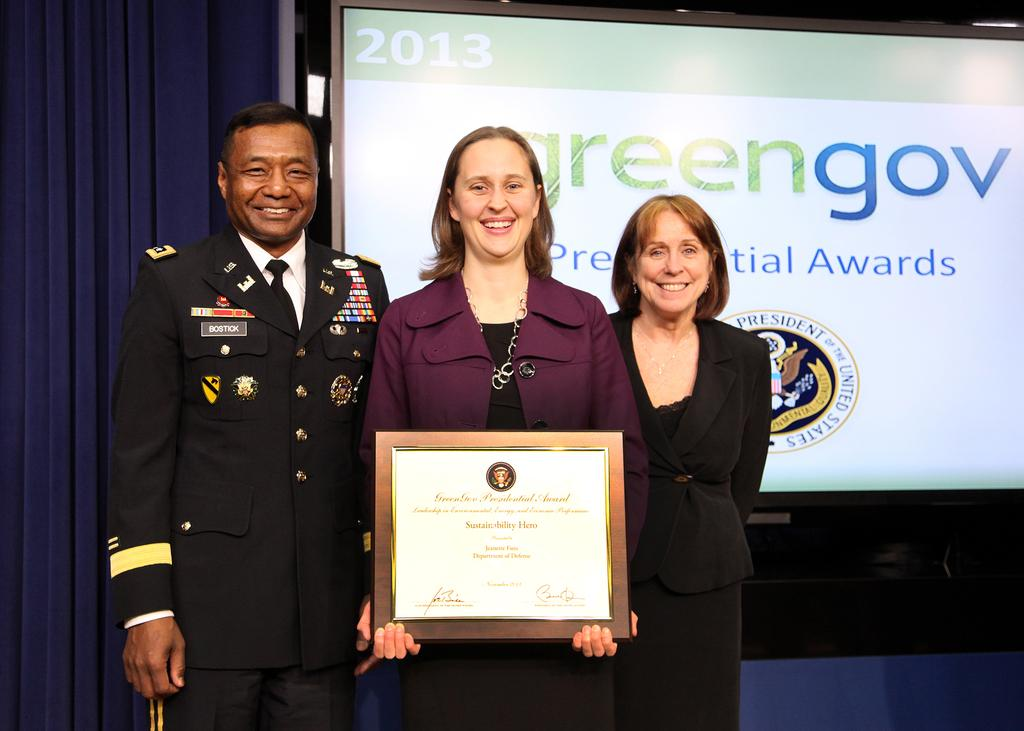How many people are present in the image? There are three persons standing in the image. What is the facial expression of the people in the image? The persons are smiling. What is one person holding in the image? One person is holding a certificate. What can be seen in the background of the image? There is a screen in the background of the image. What is the name of the daughter of the person holding the certificate in the image? There is no mention of a daughter or any family relationship in the image. 